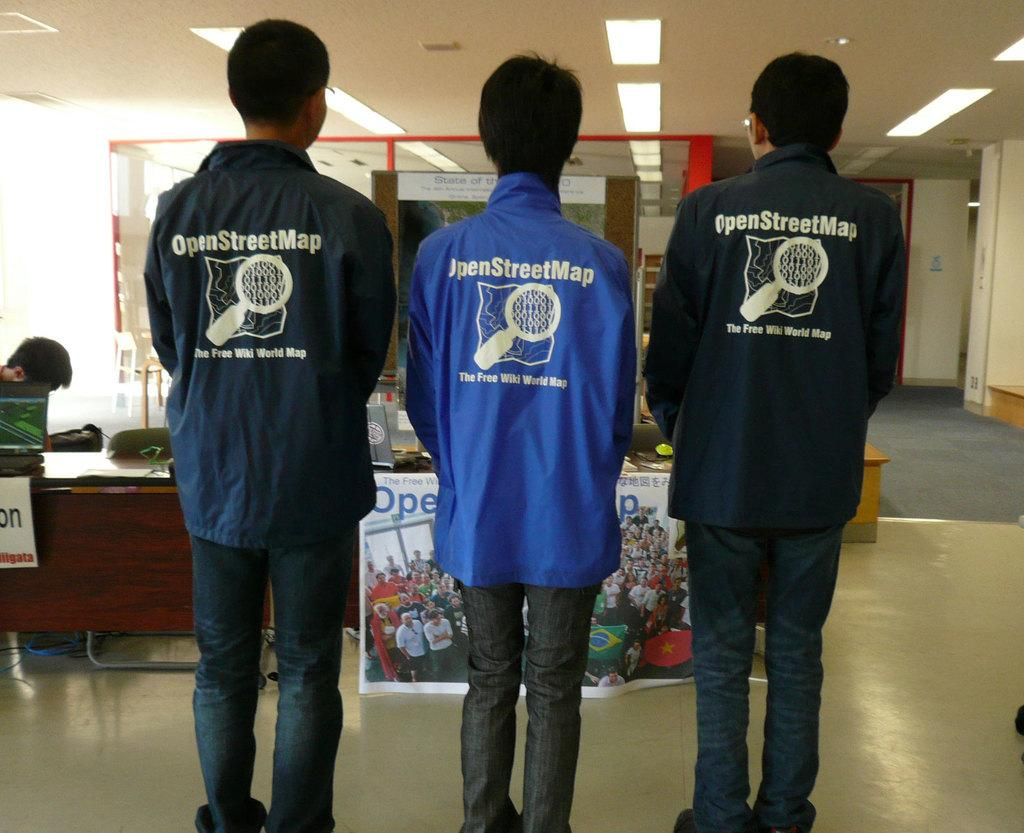Provide a one-sentence caption for the provided image. Several young men wear windbreakers from the OpenStreetMap project. 